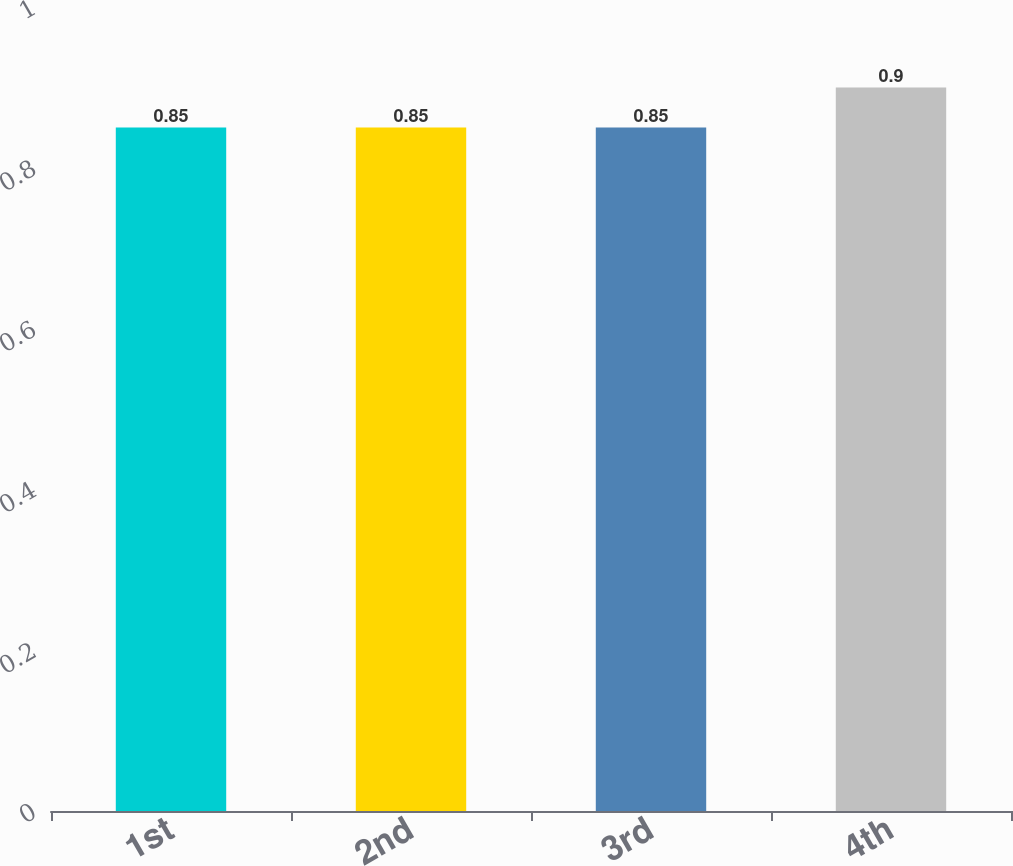Convert chart. <chart><loc_0><loc_0><loc_500><loc_500><bar_chart><fcel>1st<fcel>2nd<fcel>3rd<fcel>4th<nl><fcel>0.85<fcel>0.85<fcel>0.85<fcel>0.9<nl></chart> 